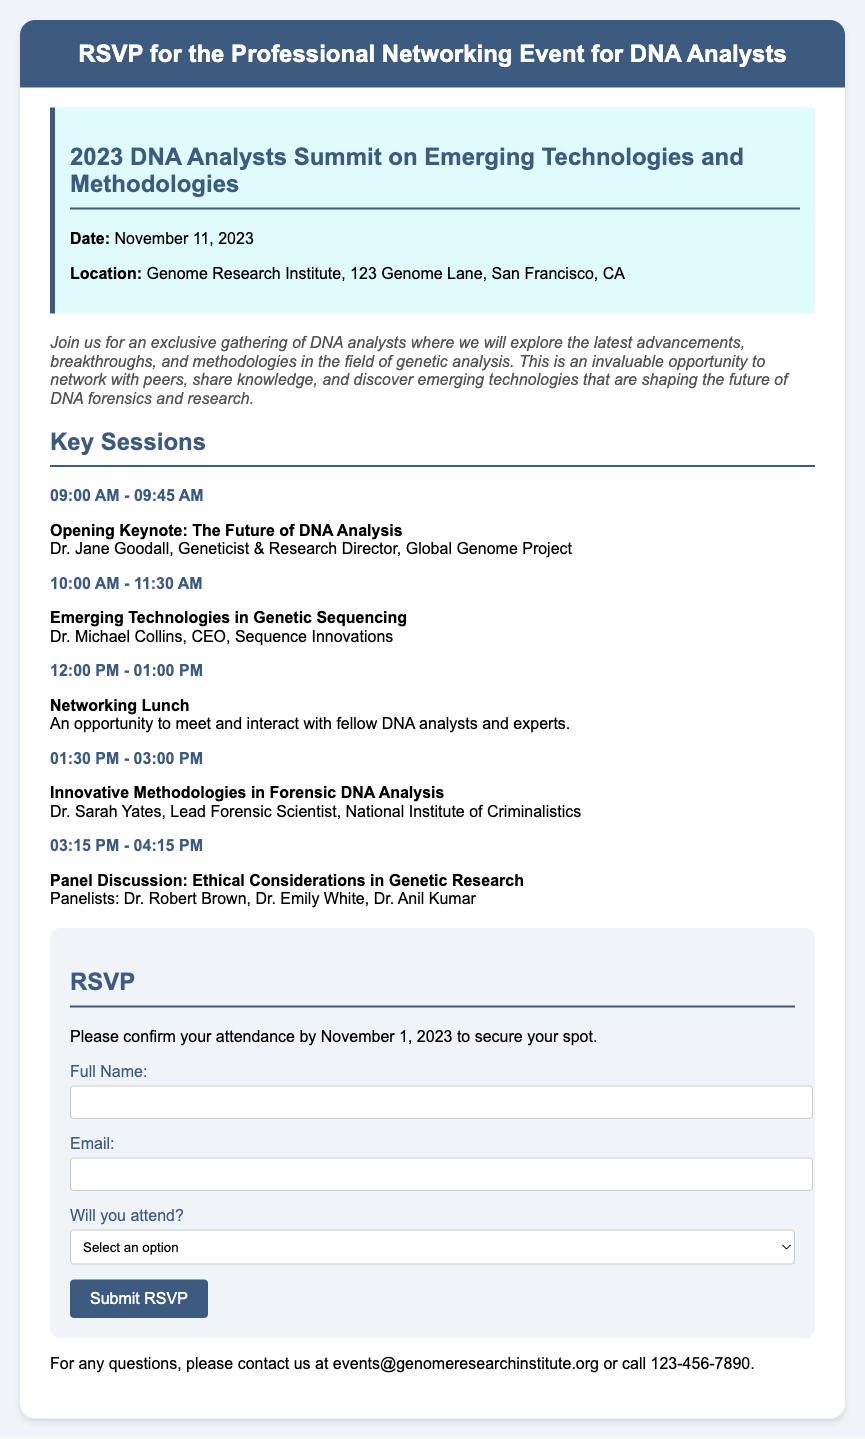What is the date of the event? The date of the event is specified in the document as November 11, 2023.
Answer: November 11, 2023 Where is the event located? The location of the event is listed as Genome Research Institute, 123 Genome Lane, San Francisco, CA.
Answer: Genome Research Institute, 123 Genome Lane, San Francisco, CA Who is the opening keynote speaker? The document identifies Dr. Jane Goodall as the opening keynote speaker.
Answer: Dr. Jane Goodall What time does the networking lunch start? The time for the networking lunch is given as 12:00 PM.
Answer: 12:00 PM How many key sessions are listed in the agenda? The agenda includes five key sessions, as detailed in the document.
Answer: 5 What is required for attendance confirmation? The document states that confirmation for attendance requires a reply by November 1, 2023.
Answer: November 1, 2023 What is the email contact for inquiries? The email provided for inquiries is events@genomeresearchinstitute.org.
Answer: events@genomeresearchinstitute.org What option should be selected if attending? If attending, the option "Yes, I will attend" should be selected on the RSVP form.
Answer: Yes, I will attend What is the format of this document? The format of the document is an RSVP card for a professional networking event.
Answer: RSVP card 